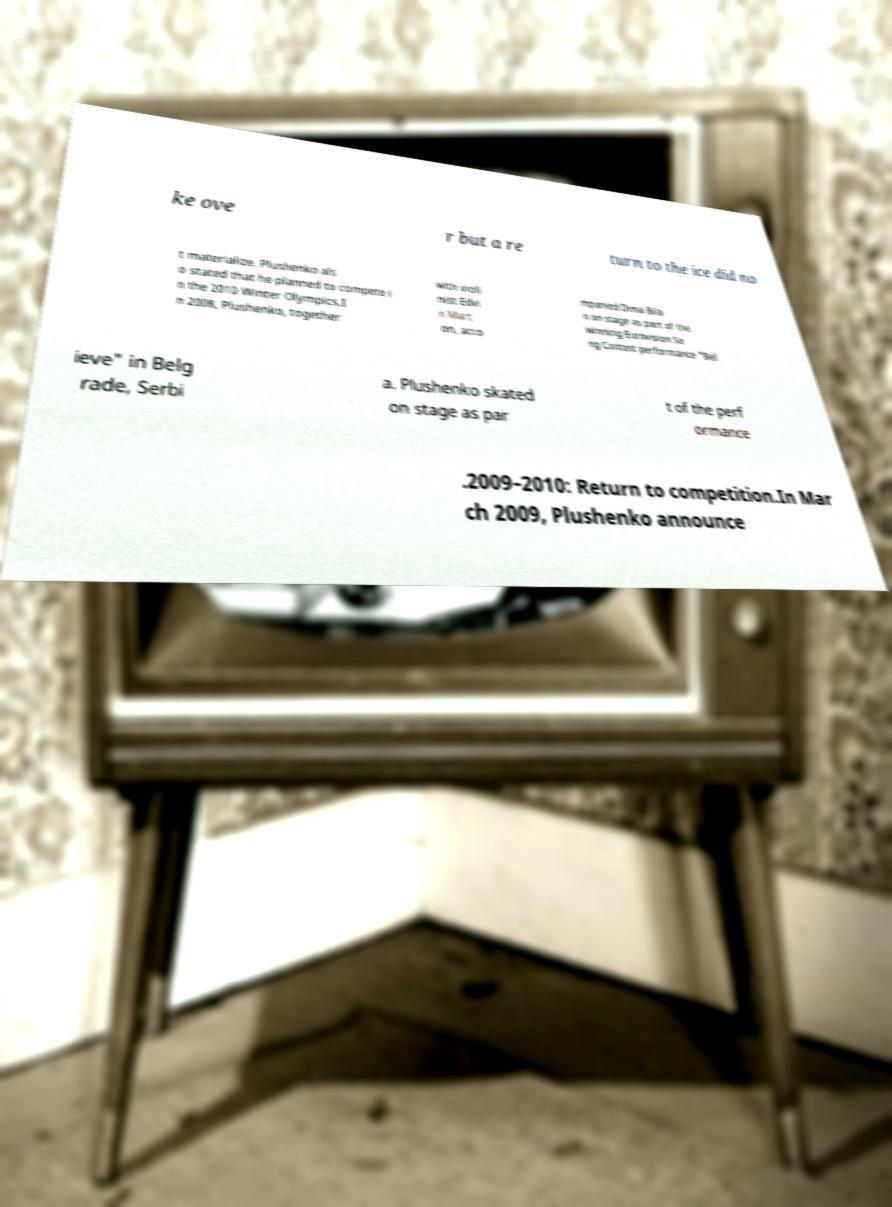I need the written content from this picture converted into text. Can you do that? ke ove r but a re turn to the ice did no t materialize. Plushenko als o stated that he planned to compete i n the 2010 Winter Olympics.I n 2008, Plushenko, together with violi nist Edvi n Mart on, acco mpanied Dima Bila n on stage as part of the winning Eurovision So ng Contest performance "Bel ieve" in Belg rade, Serbi a. Plushenko skated on stage as par t of the perf ormance .2009–2010: Return to competition.In Mar ch 2009, Plushenko announce 